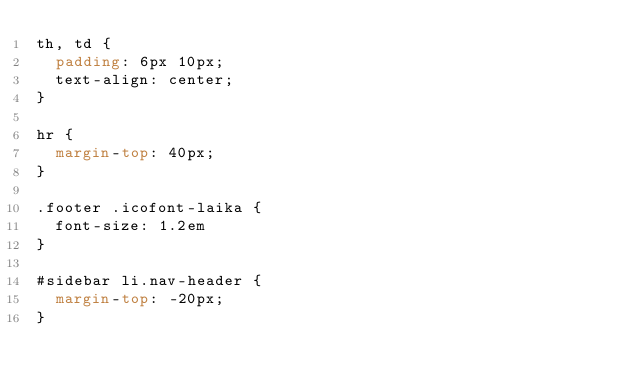Convert code to text. <code><loc_0><loc_0><loc_500><loc_500><_CSS_>th, td {
  padding: 6px 10px;
  text-align: center;
}

hr {
  margin-top: 40px;
}

.footer .icofont-laika {
  font-size: 1.2em
}

#sidebar li.nav-header {
  margin-top: -20px;
}
</code> 